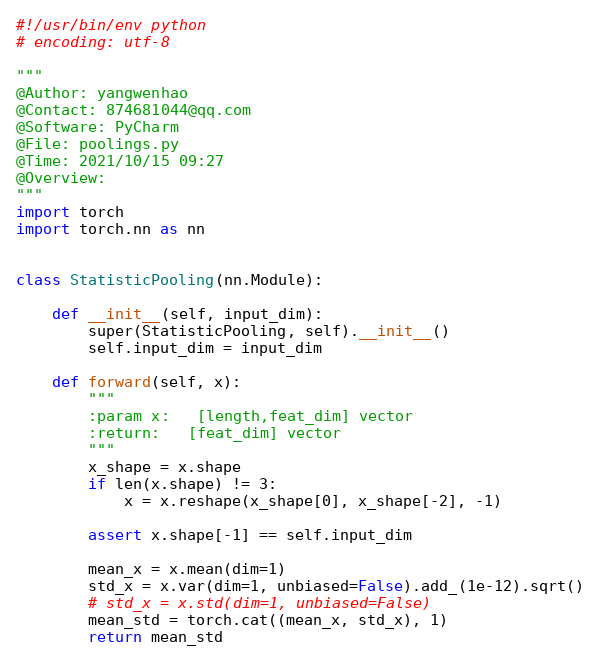<code> <loc_0><loc_0><loc_500><loc_500><_Python_>#!/usr/bin/env python
# encoding: utf-8

"""
@Author: yangwenhao
@Contact: 874681044@qq.com
@Software: PyCharm
@File: poolings.py
@Time: 2021/10/15 09:27
@Overview:
"""
import torch
import torch.nn as nn


class StatisticPooling(nn.Module):

    def __init__(self, input_dim):
        super(StatisticPooling, self).__init__()
        self.input_dim = input_dim

    def forward(self, x):
        """
        :param x:   [length,feat_dim] vector
        :return:   [feat_dim] vector
        """
        x_shape = x.shape
        if len(x.shape) != 3:
            x = x.reshape(x_shape[0], x_shape[-2], -1)

        assert x.shape[-1] == self.input_dim

        mean_x = x.mean(dim=1)
        std_x = x.var(dim=1, unbiased=False).add_(1e-12).sqrt()
        # std_x = x.std(dim=1, unbiased=False)
        mean_std = torch.cat((mean_x, std_x), 1)
        return mean_std
</code> 